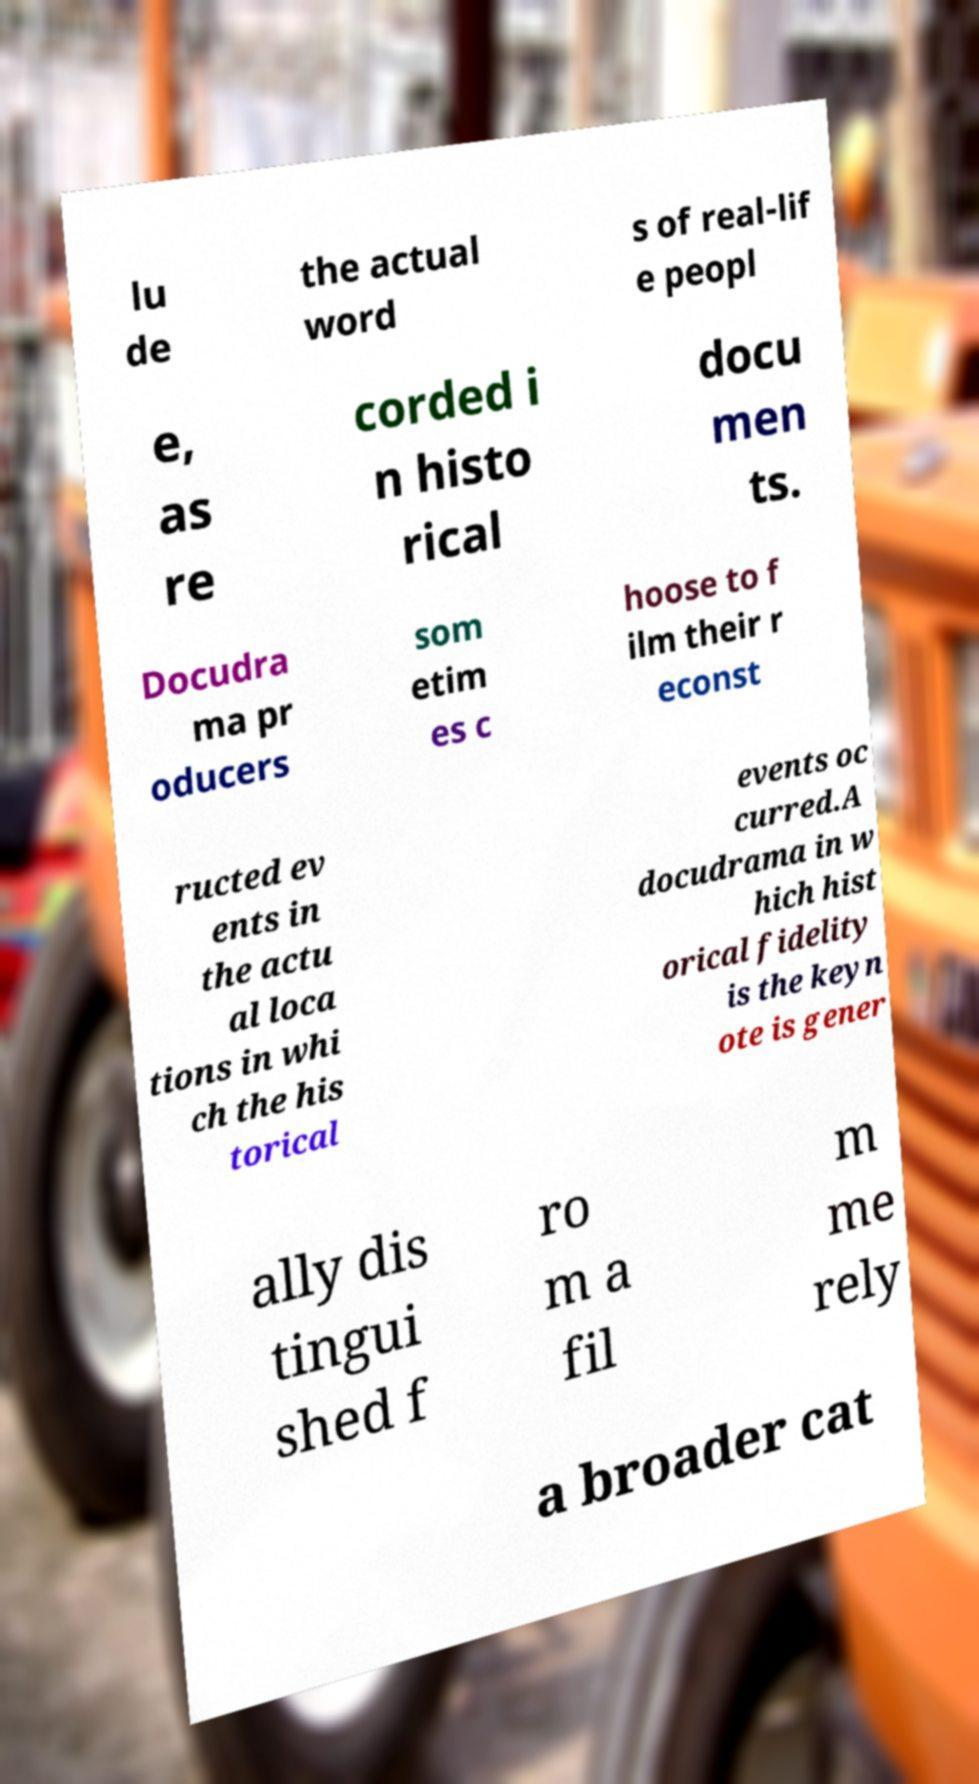What messages or text are displayed in this image? I need them in a readable, typed format. lu de the actual word s of real-lif e peopl e, as re corded i n histo rical docu men ts. Docudra ma pr oducers som etim es c hoose to f ilm their r econst ructed ev ents in the actu al loca tions in whi ch the his torical events oc curred.A docudrama in w hich hist orical fidelity is the keyn ote is gener ally dis tingui shed f ro m a fil m me rely a broader cat 